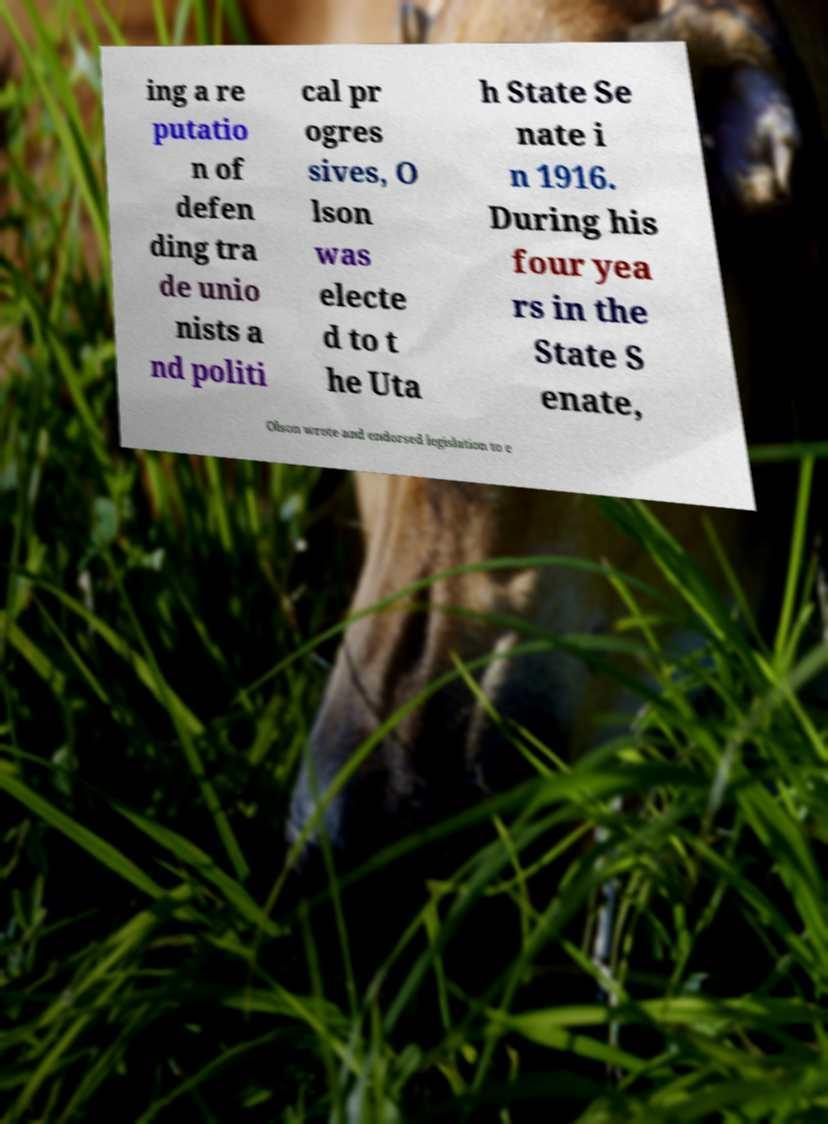Please identify and transcribe the text found in this image. ing a re putatio n of defen ding tra de unio nists a nd politi cal pr ogres sives, O lson was electe d to t he Uta h State Se nate i n 1916. During his four yea rs in the State S enate, Olson wrote and endorsed legislation to e 